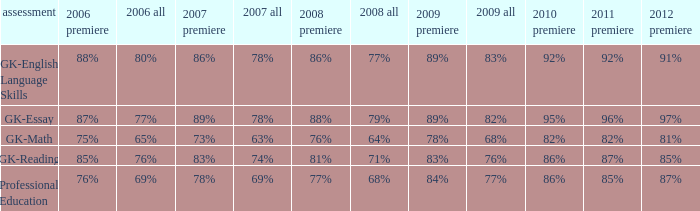What is the percentage for first time in 2012 when it was 82% for all in 2009? 97%. 